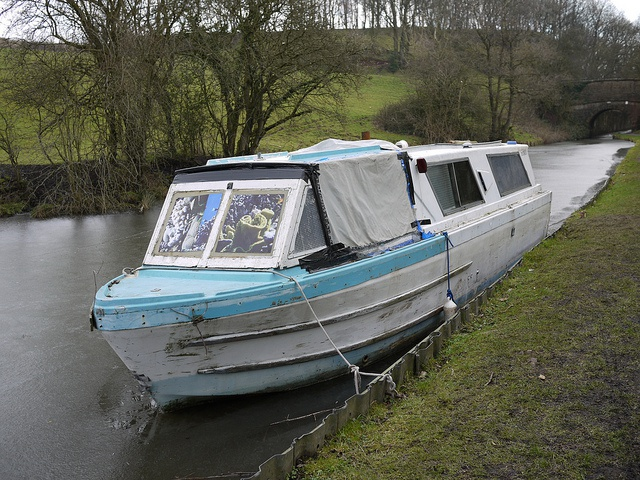Describe the objects in this image and their specific colors. I can see a boat in lightgray, gray, darkgray, and black tones in this image. 